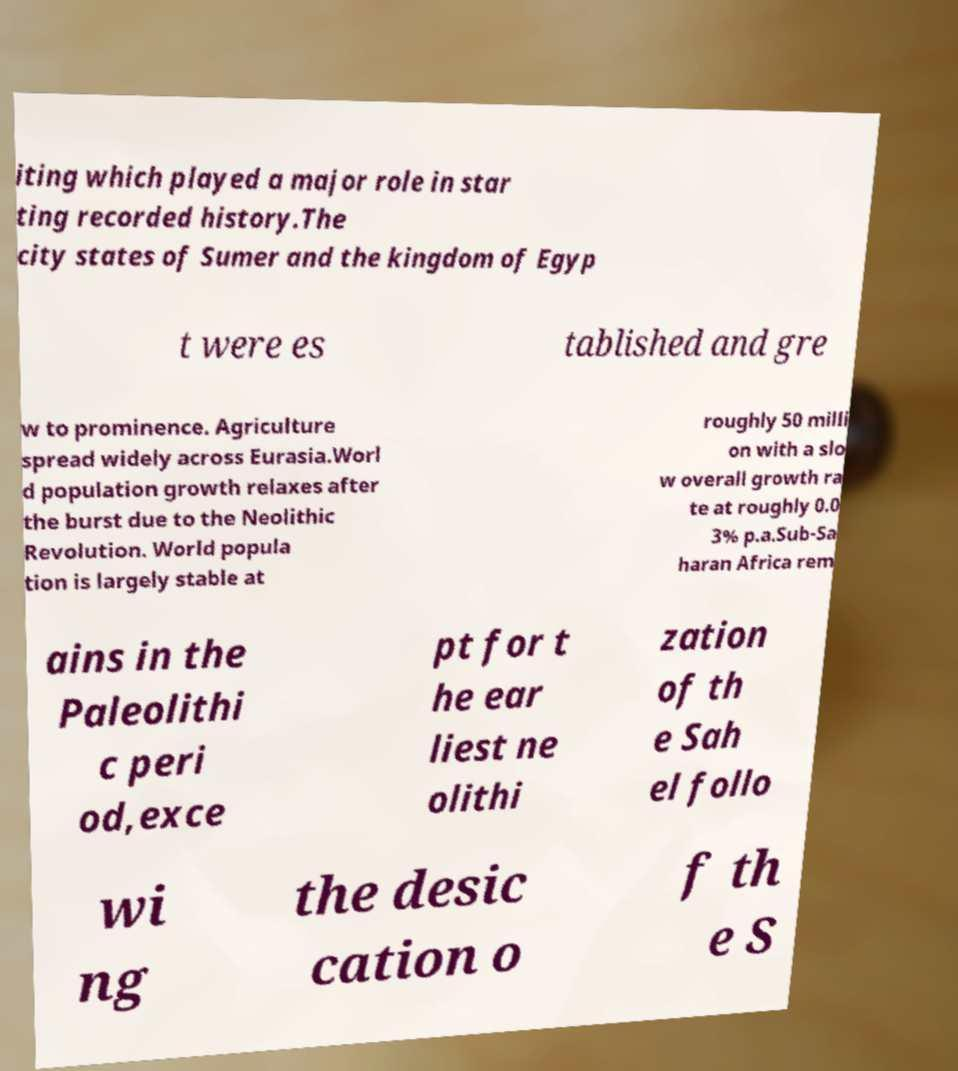Can you read and provide the text displayed in the image?This photo seems to have some interesting text. Can you extract and type it out for me? iting which played a major role in star ting recorded history.The city states of Sumer and the kingdom of Egyp t were es tablished and gre w to prominence. Agriculture spread widely across Eurasia.Worl d population growth relaxes after the burst due to the Neolithic Revolution. World popula tion is largely stable at roughly 50 milli on with a slo w overall growth ra te at roughly 0.0 3% p.a.Sub-Sa haran Africa rem ains in the Paleolithi c peri od,exce pt for t he ear liest ne olithi zation of th e Sah el follo wi ng the desic cation o f th e S 